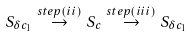<formula> <loc_0><loc_0><loc_500><loc_500>S _ { \delta c _ { 1 } } \stackrel { s t e p ( i i ) } { \rightarrow } S _ { c } \stackrel { s t e p ( i i i ) } { \rightarrow } S _ { \delta c _ { 1 } }</formula> 